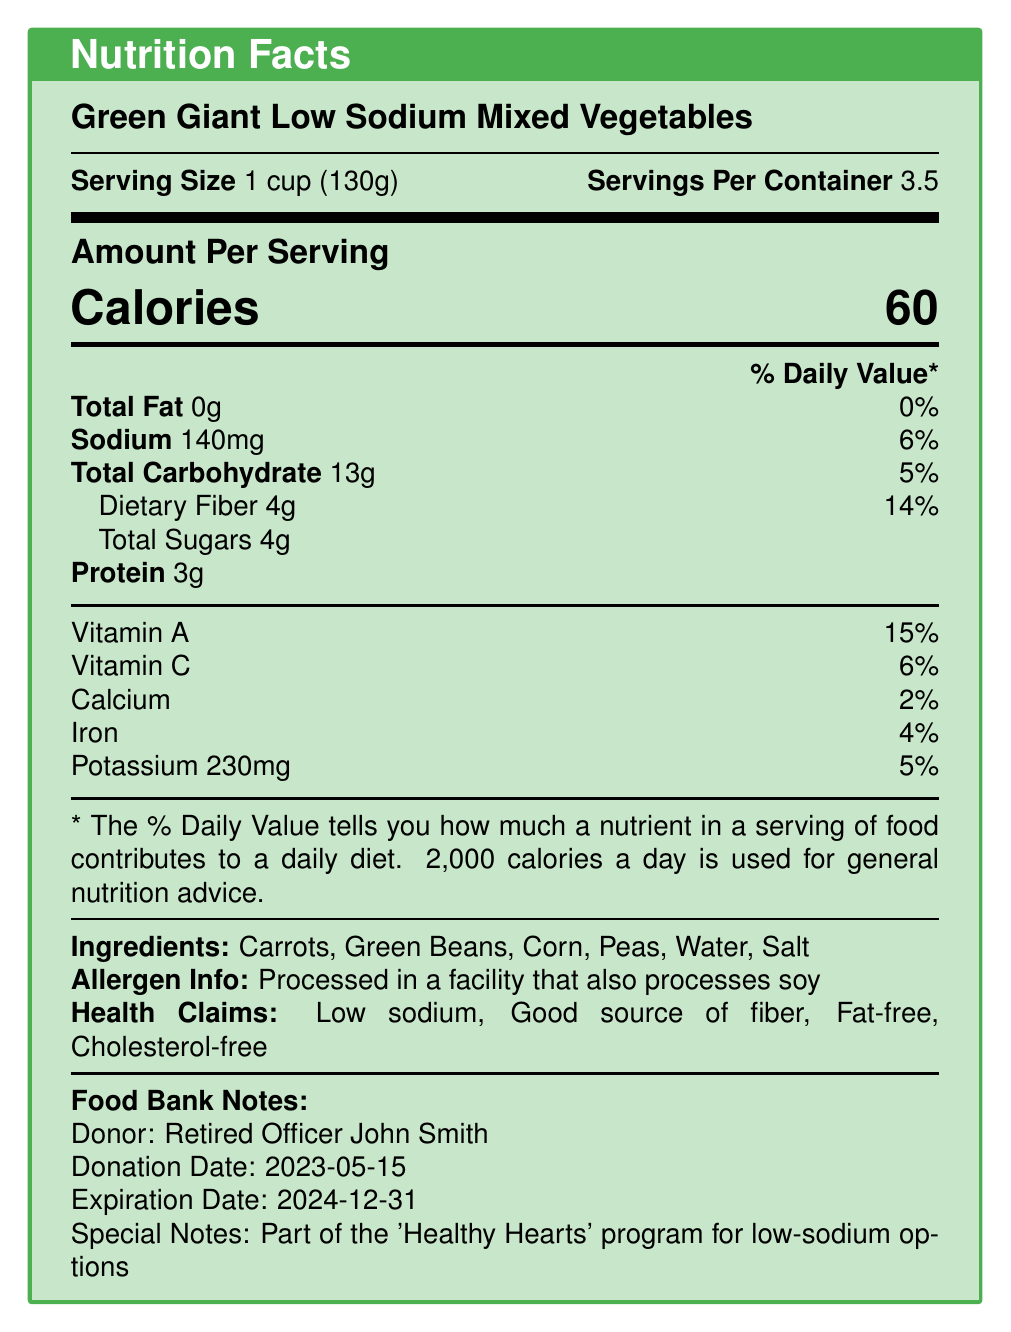what is the serving size? The serving size is explicitly mentioned as "1 cup (130g)" in the document.
Answer: 1 cup (130g) how many servings are there per container? The document states that there are "3.5" servings per container.
Answer: 3.5 how many calories are in one serving? One serving contains "60" calories as noted in the document.
Answer: 60 what percentage of daily value does dietary fiber provide? The dietary fiber provides "14%" of the daily value according to the document.
Answer: 14% what ingredients are included in the product? The ingredients listed in the document include "Carrots, Green Beans, Corn, Peas, Water, Salt".
Answer: Carrots, Green Beans, Corn, Peas, Water, Salt what is the total amount of carbohydrate per serving? The total amount of carbohydrate per serving is "13g" according to the document.
Answer: 13g which nutrient has the lowest daily value percentage? A. Vitamin A B. Calcium C. Iron D. Sodium Calcium has the lowest daily value percentage at "2%" in the document.
Answer: B how much sodium is in one serving? A. 140mg B. 6% C. 60mg D. 4g The sodium content in one serving is "140mg" as noted in the document.
Answer: A is this product fat-free? The document states "0g" of total fat and includes a health claim specifying that the product is "Fat-free."
Answer: Yes is this item suitable for someone who needs a high-protein diet? With only "3g" of protein per serving, this product does not provide a high-protein diet.
Answer: No summarize the main idea of the document. The main idea focuses on the nutritional content and health benefits of the canned vegetables, while also providing additional contextual information about the donor and the purpose of the donation.
Answer: The document provides detailed nutrition facts for "Green Giant Low Sodium Mixed Vegetables," highlighting its low sodium content, high dietary fiber, and noting that it is fat-free and cholesterol-free. It also lists the ingredients, allergen information, and additional notes from the food bank about the donor and health program. what is the donation date of this product? According to the document, the donation date is "2023-05-15."
Answer: 2023-05-15 processed in a facility that also processes what allergen? The allergen information notes that the product is processed in a facility that also processes "soy."
Answer: Soy what program is this donation part of? The food bank notes indicate that this donation is part of the "'Healthy Hearts' program for low-sodium options."
Answer: 'Healthy Hearts' program for low-sodium options how much iron is there per serving? The document mentions that there is "0.7mg" of iron per serving.
Answer: 0.7mg is this product suitable for someone with soy allergies? The document states that it is processed in a facility that also processes soy, but it does not confirm whether the product itself has soy.
Answer: Cannot be determined 